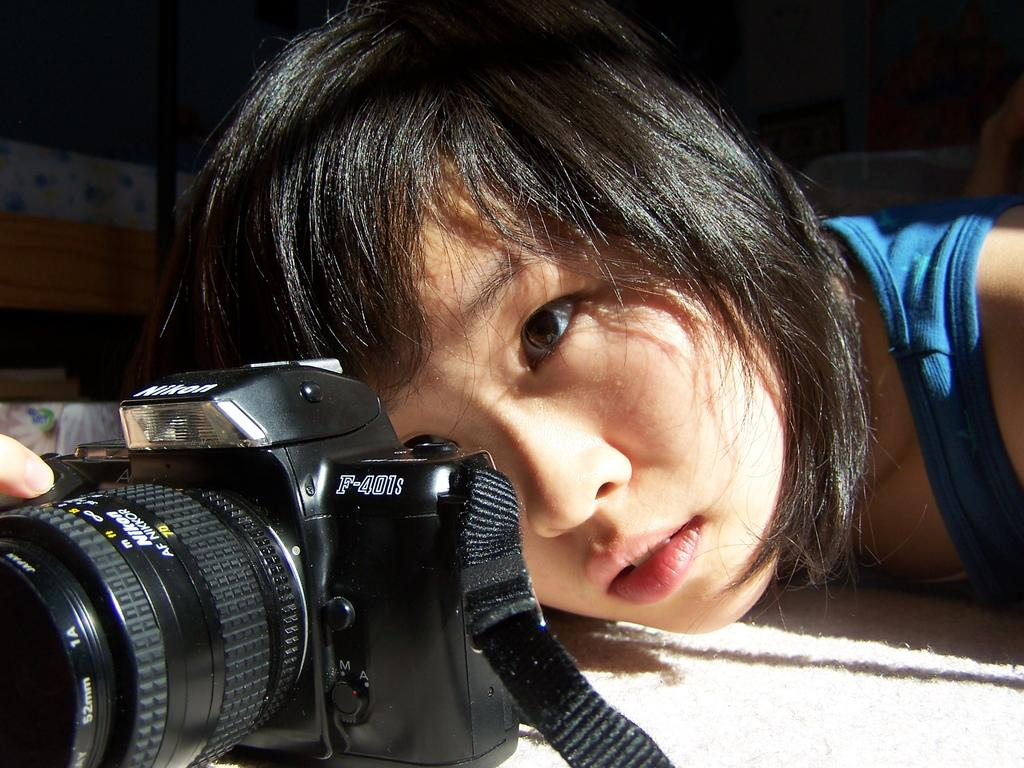Who is the main subject in the image? There is a woman in the image. What is the woman holding in the image? The woman is holding a camera. How does the woman manage to control the crowd with her camera in the image? There is no crowd present in the image, and the woman is not controlling any crowd with her camera. 